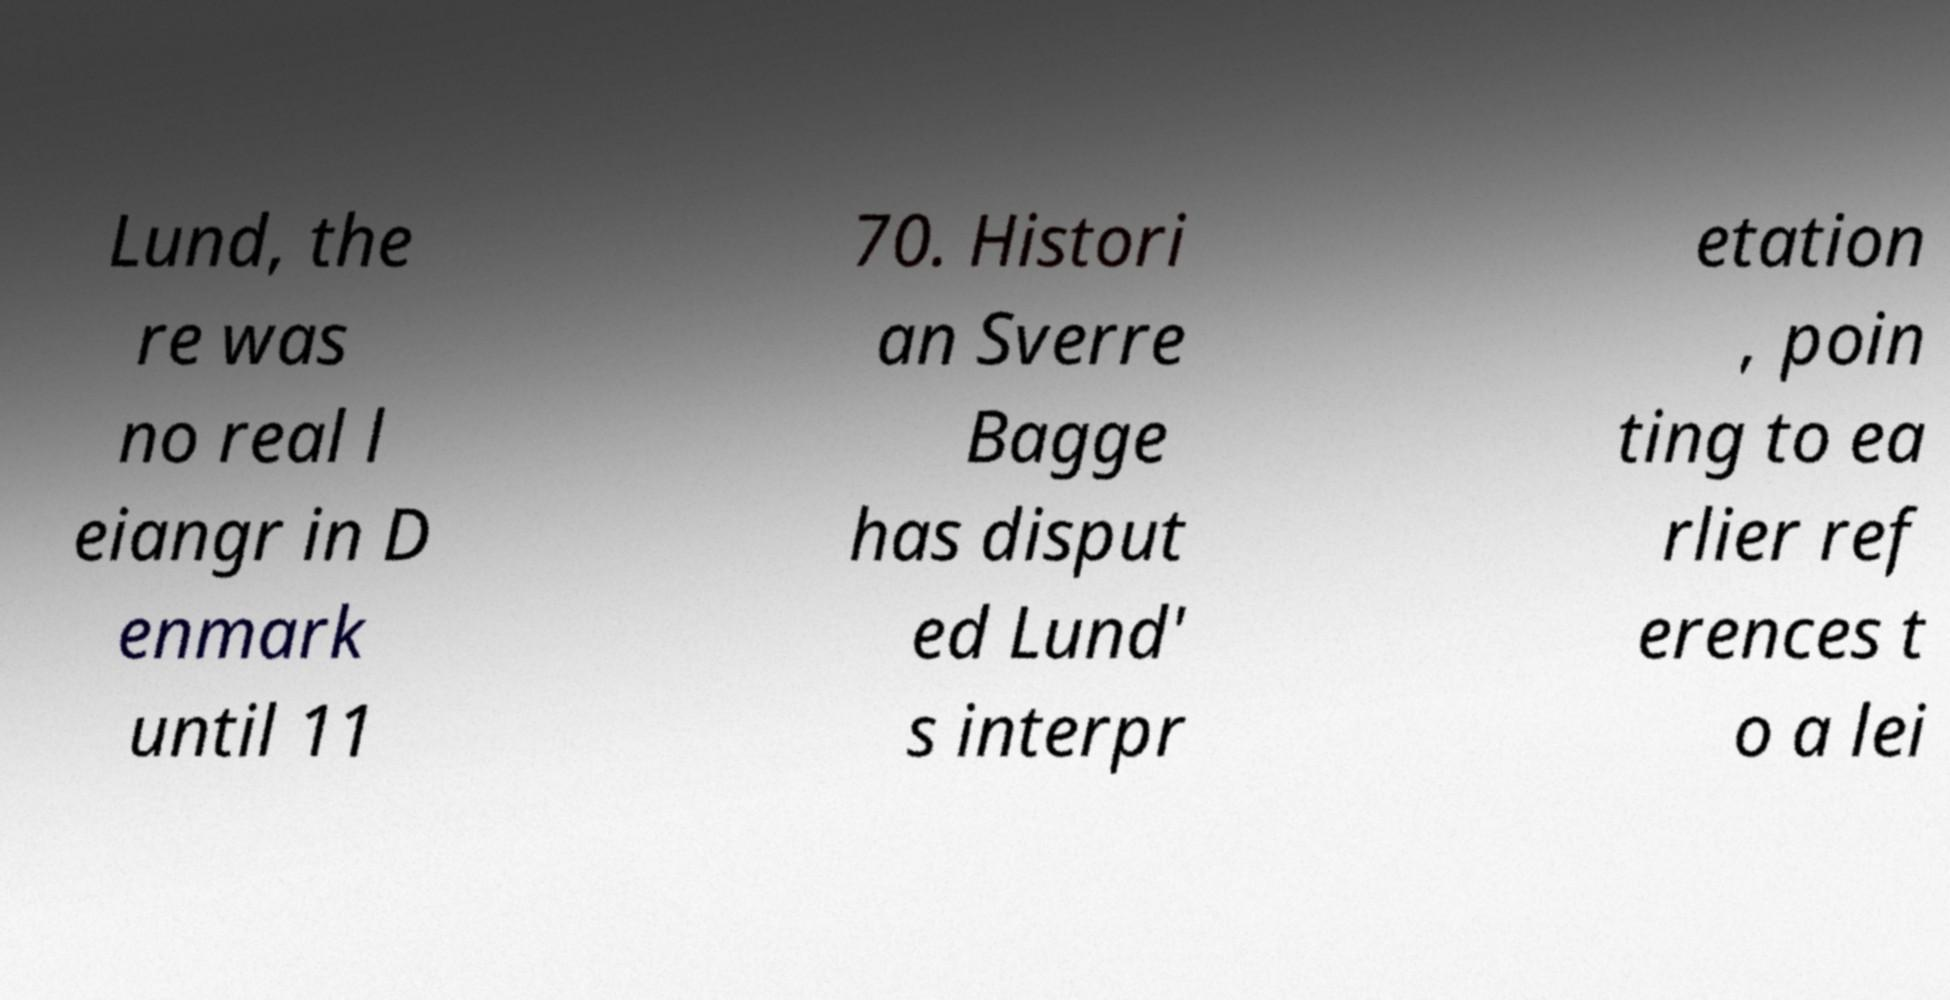Can you accurately transcribe the text from the provided image for me? Lund, the re was no real l eiangr in D enmark until 11 70. Histori an Sverre Bagge has disput ed Lund' s interpr etation , poin ting to ea rlier ref erences t o a lei 